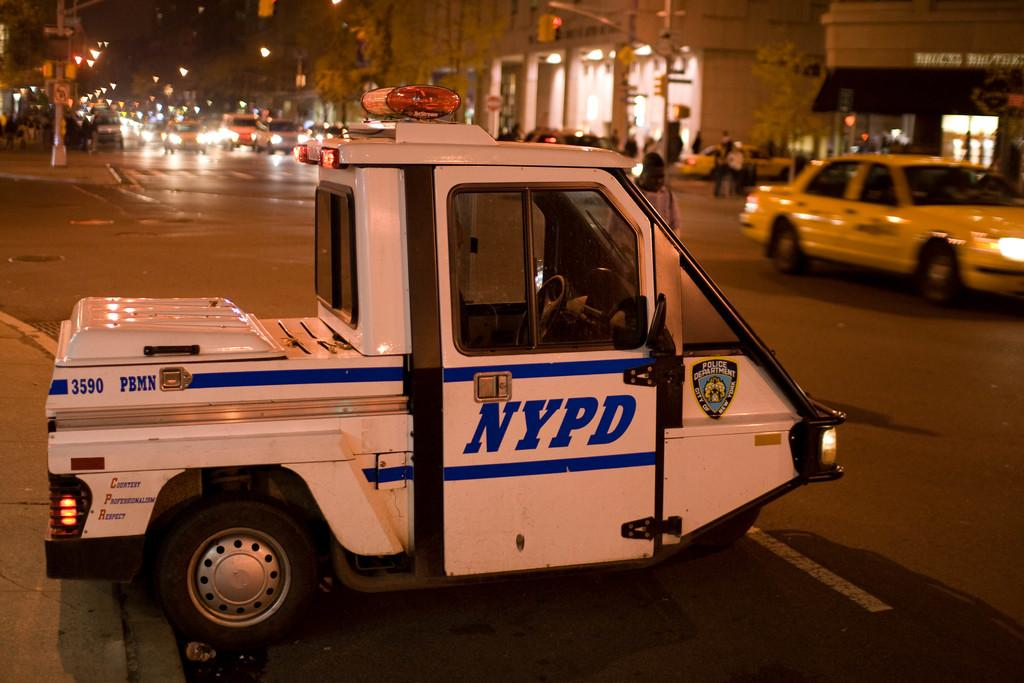<image>
Provide a brief description of the given image. a vehicle that has NYPD written on it 